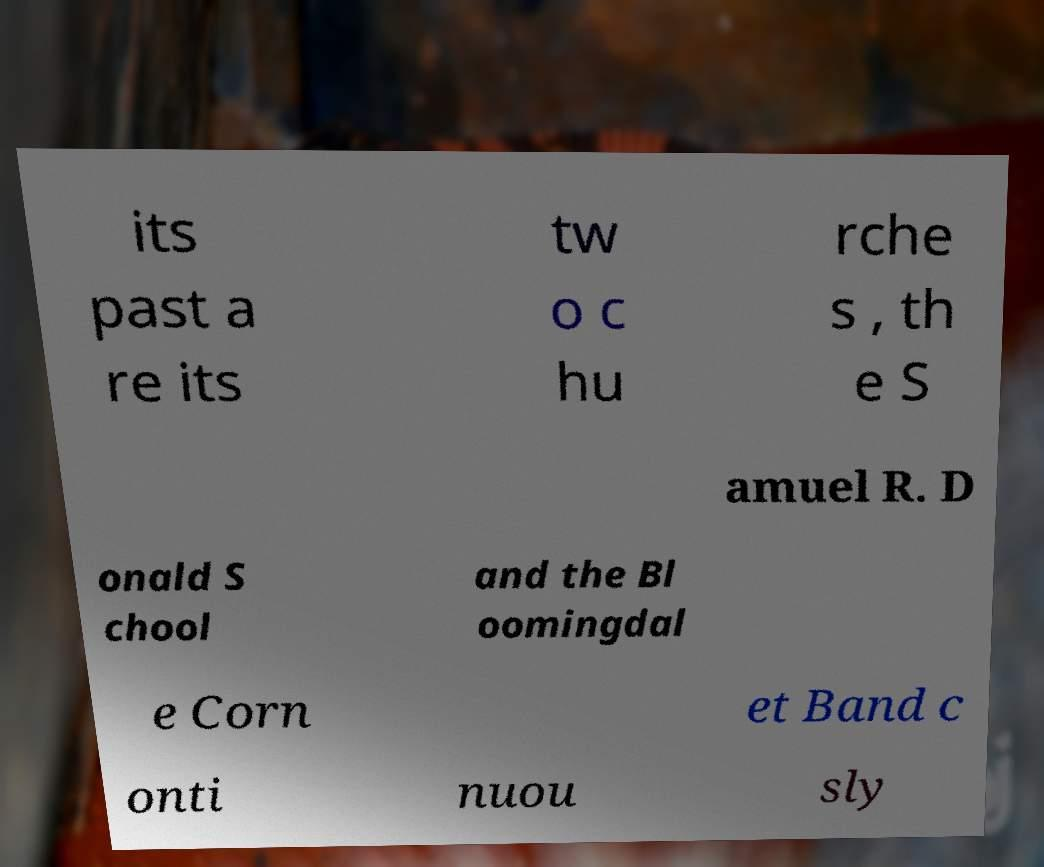What messages or text are displayed in this image? I need them in a readable, typed format. its past a re its tw o c hu rche s , th e S amuel R. D onald S chool and the Bl oomingdal e Corn et Band c onti nuou sly 